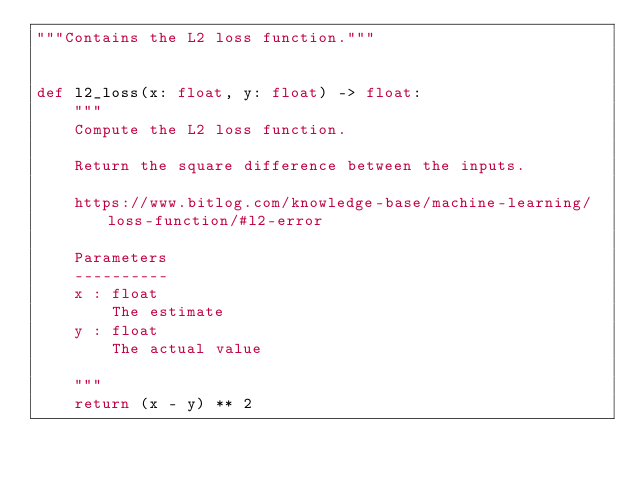Convert code to text. <code><loc_0><loc_0><loc_500><loc_500><_Python_>"""Contains the L2 loss function."""


def l2_loss(x: float, y: float) -> float:
    """
    Compute the L2 loss function.

    Return the square difference between the inputs.

    https://www.bitlog.com/knowledge-base/machine-learning/loss-function/#l2-error

    Parameters
    ----------
    x : float
        The estimate
    y : float
        The actual value

    """
    return (x - y) ** 2
</code> 